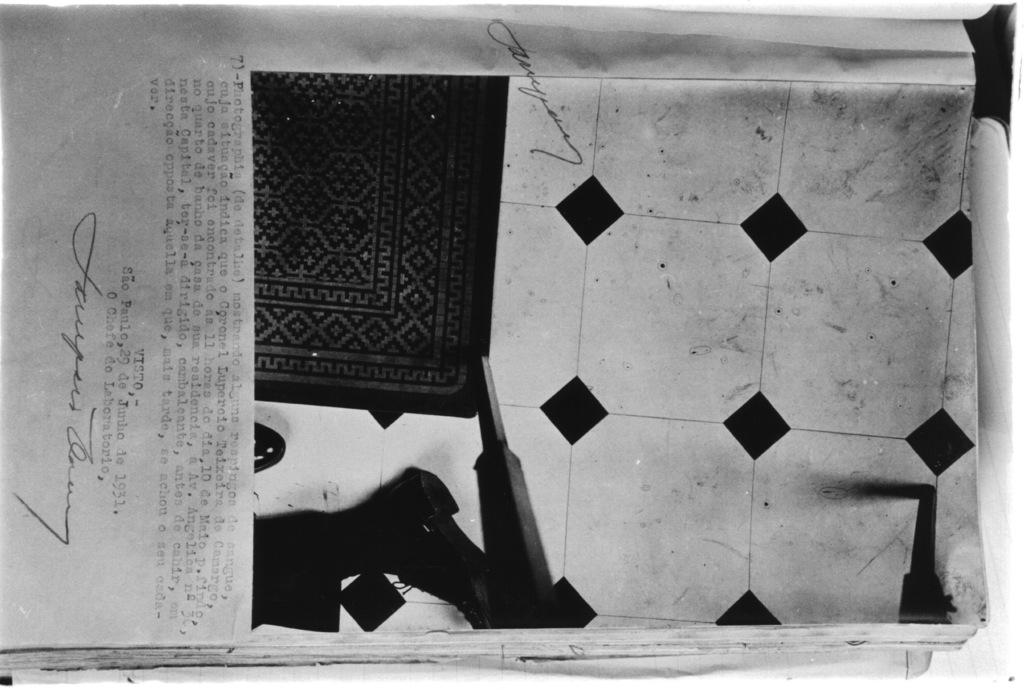What is the color scheme of the image? The image is black and white. What can be seen in the image? There is a book in the image. What is depicted on the page of the book? The page contains a carpet on the floor and some objects. Are there any words on the page? Yes, the page contains some text. How many teeth can be seen on the carpet in the image? There are no teeth visible on the carpet in the image. 